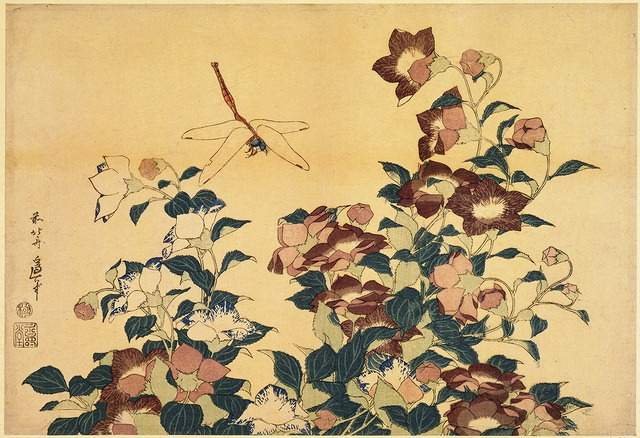Why is this particular style of painting, with bold lines and flat colors, used in ukiyo-e? Ukiyo-e, translated as 'pictures of the floating world,' utilizes bold lines and flat areas of color to create visually striking images that could be easily reproduced using woodblock printing techniques. This style was ideal for conveying clear and vibrant imagery even when replicated in large numbers. The technique emphasizes clean contours and minimalistic yet expressive color schemes, making the artwork accessible and appealing to the masses during Edo Japan, serving both artistic and commercial needs. 